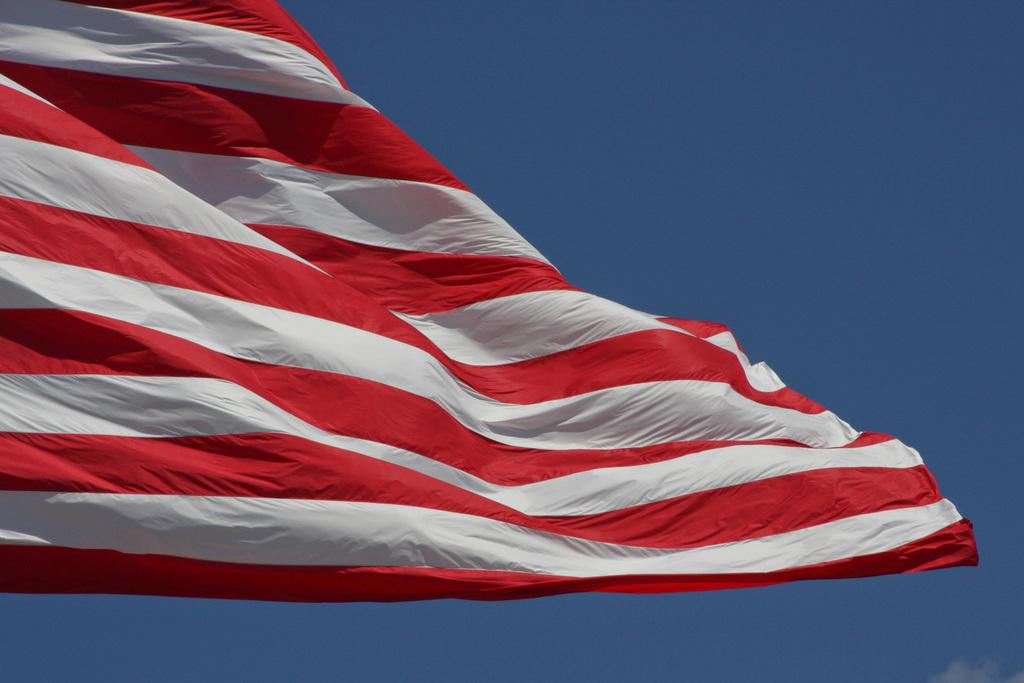What is present in the image that represents a symbol or country? There is a flag in the image. What can be seen in the background of the image? The sky is visible in the background of the image. What type of cart is being used to transport goods on the farm in the image? There is no cart or farm present in the image; it only features a flag and the sky. 